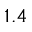<formula> <loc_0><loc_0><loc_500><loc_500>1 . 4</formula> 